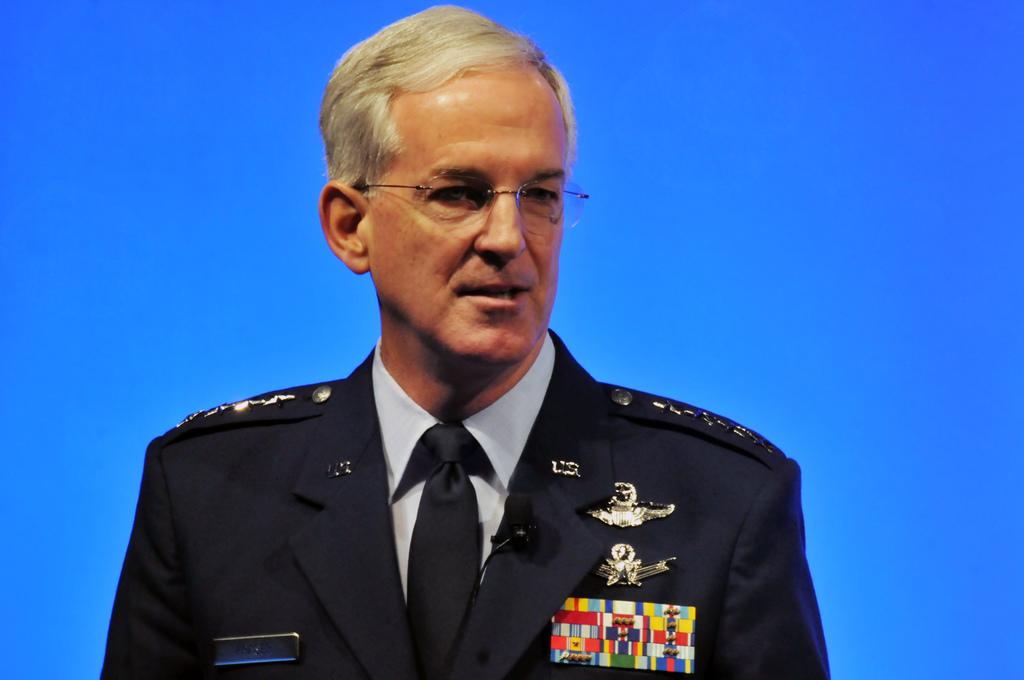What is the main subject of the image? There is a man in the image. What is the man wearing? The man is wearing a uniform. What color is the background of the image? The background of the image is blue. How many times does the man cough in the image? There is no indication of the man coughing in the image. What type of shade is covering the man in the image? There is no shade covering the man in the image. 